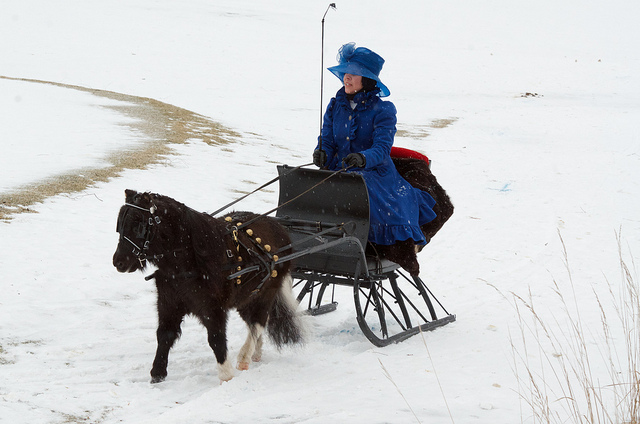Is this a large horse?
Answer the question using a single word or phrase. No Is the horse running? No How many people are riding on this sled? 1 